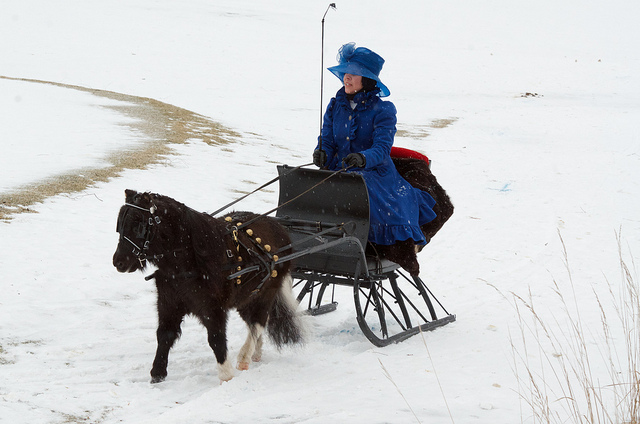Is this a large horse?
Answer the question using a single word or phrase. No Is the horse running? No How many people are riding on this sled? 1 